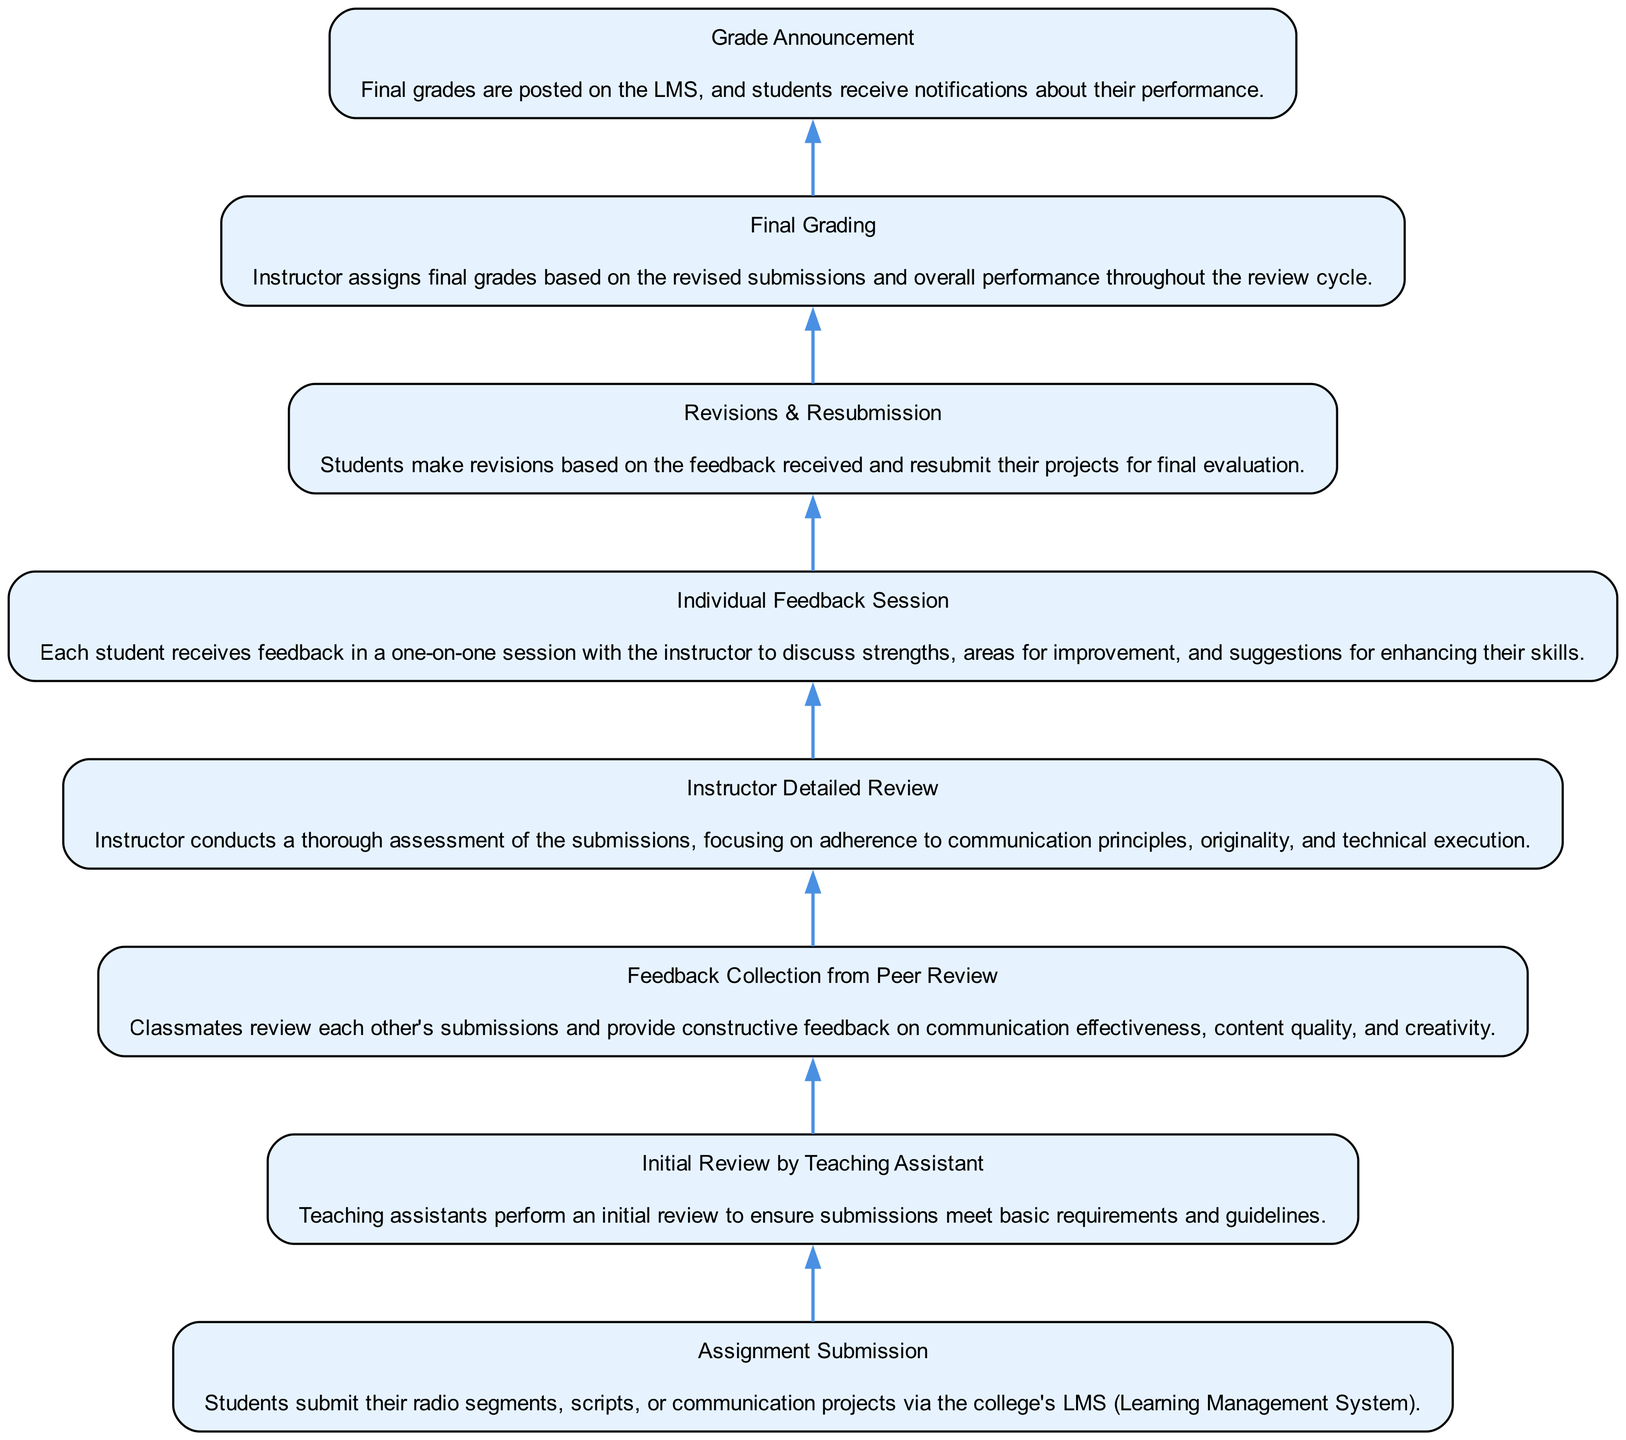What's the first step in the feedback cycle? The first step, as indicated in the diagram, is "Assignment Submission," where students submit their projects via the LMS.
Answer: Assignment Submission How many nodes are there in the diagram? There are eight nodes in the diagram, each representing a distinct step in the student feedback cycle.
Answer: 8 What follows "Initial Review by Teaching Assistant"? After "Initial Review by Teaching Assistant," the next step in the cycle is "Feedback Collection from Peer Review."
Answer: Feedback Collection from Peer Review Which step involves one-on-one discussions? The step that involves one-on-one discussions is "Individual Feedback Session," where the instructor talks with each student about their performance.
Answer: Individual Feedback Session What is the final node in the cycle? The final node in the cycle is "Grade Announcement," where students are notified of their final grades.
Answer: Grade Announcement What step comes before "Final Grading"? Before "Final Grading," students go through "Revisions & Resubmission," where they make adjustments based on the feedback received.
Answer: Revisions & Resubmission What type of feedback is collected from classmates? Classmates provide "constructive feedback" on each other's submissions regarding communication effectiveness, content quality, and creativity during "Feedback Collection from Peer Review."
Answer: Constructive feedback How does the feedback cycle ensure students improve? The feedback cycle includes several steps where students receive varied feedback and can revise their work, particularly in "Individual Feedback Session" and "Revisions & Resubmission," fostering improvement through iterative learning.
Answer: Iterative learning 